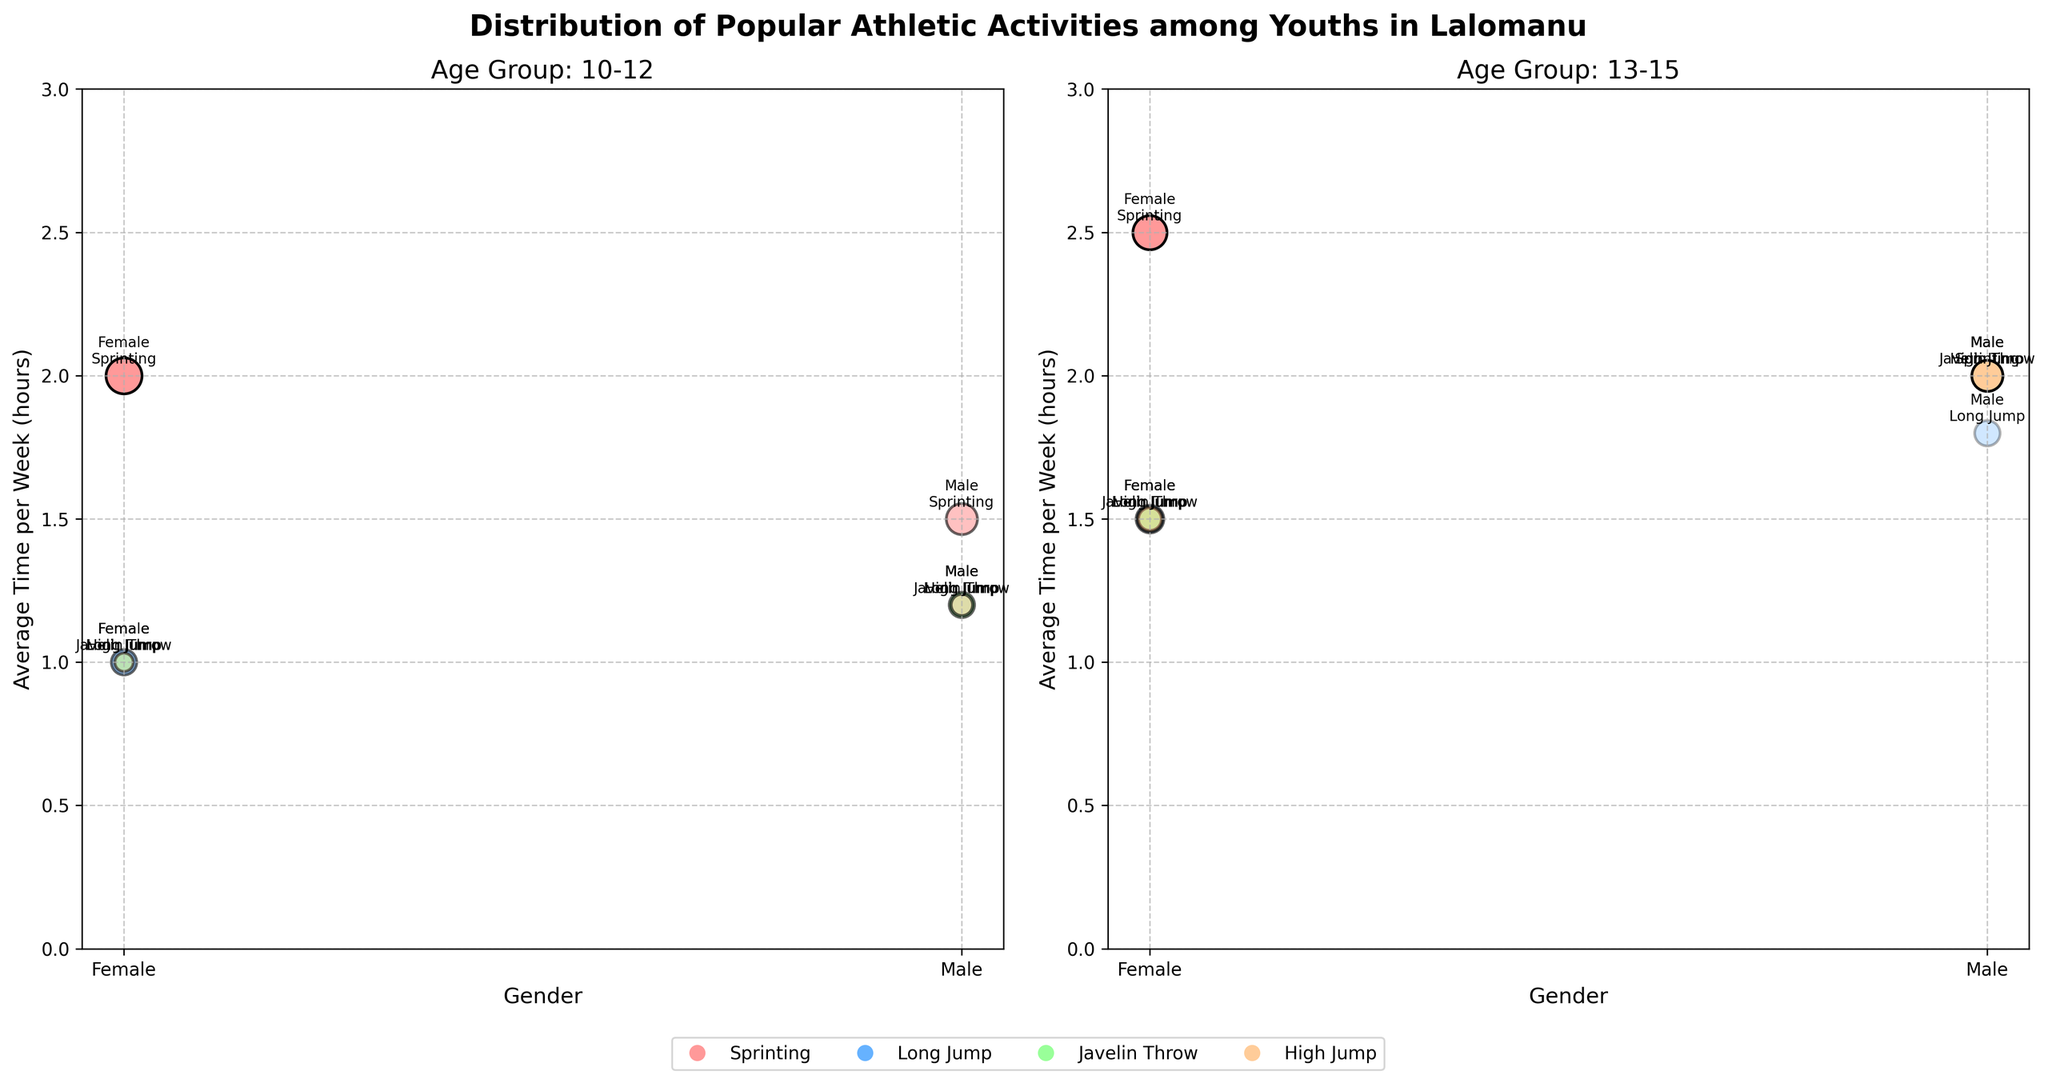How many activities are shown in each subplot? Both subplots show four activities: Sprinting, Long Jump, Javelin Throw, and High Jump.
Answer: Four activities Which gender spends more average time per week on High Jump in the 13-15 age group? In the subplot for the 13-15 age group, the male bubble for High Jump is higher on the y-axis than the female bubble, indicating males spend more average time per week.
Answer: Males Which activity has the highest enthusiasm level among females aged 10-12? The subplot for 10-12 ages shows that Sprinting has the most opaque (least transparent) bubble among females, indicating the highest enthusiasm level.
Answer: Sprinting Compare the participant counts for Sprinting in both age groups and genders. In the 10-12 age group, there are 20 females and 15 males. In the 13-15 age group, there are 18 females and 12 males. Therefore, the total participant count is 20+15=35 for 10-12 and 18+12=30 for 13-15.
Answer: 35 for 10-12 and 30 for 13-15 What is the size comparison of the bubbles representing Long Jump for each gender in the 10-12 age group? The subplot for 10-12 shows that the female bubble for Long Jump is larger than the male bubble, indicating more participants. Females have 10 participants while males have 8.
Answer: Female > Male Which group of males has the lowest enthusiasm for their activity? In the 10-12 age group, males participating in Long Jump have the lowest enthusiasm level, indicated by a more transparent (less opaque) bubble.
Answer: 10-12 Long Jump Identify the activity and age group with an equal number of male and female participants. For Javelin Throw in the 13-15 age group, both males and females have a similar bubble size with 8 female participants and 12 male participants, which is the closest to being equal.
Answer: Javelin Throw, 13-15 age group What's the average weekly time spent on Javelin Throw by males in the 13-15 age group? The subplot for the 13-15 age group shows males’ average time per week on Javelin Throw is at 2 hours.
Answer: 2 hours Which activity shows the largest gender difference in average time spent per week within the 13-15 age group? In the 13-15 age group subplot, High Jump has a significant difference in height between male and female bubbles, with males spending more time compared to females.
Answer: High Jump Compare the enthusiasm levels of females in the 10-12 age group across all activities. In the 10-12 age group subplot, Sprinting shows the highest opacity indicating "High" enthusiasm, while Long Jump, Javelin Throw, and High Jump have "Medium" and "Low" enthusiasm levels respectively.
Answer: Sprinting: High, Long Jump: Medium, Javelin Throw: Medium, High Jump: Low 